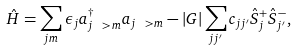<formula> <loc_0><loc_0><loc_500><loc_500>\hat { H } = \sum _ { j m } \epsilon _ { j } a ^ { \dagger } _ { j \ > m } a _ { j \ > m } - | G | \sum _ { j j ^ { \prime } } c _ { j j ^ { \prime } } \hat { S } ^ { + } _ { j } \hat { S } ^ { - } _ { j ^ { \prime } } ,</formula> 